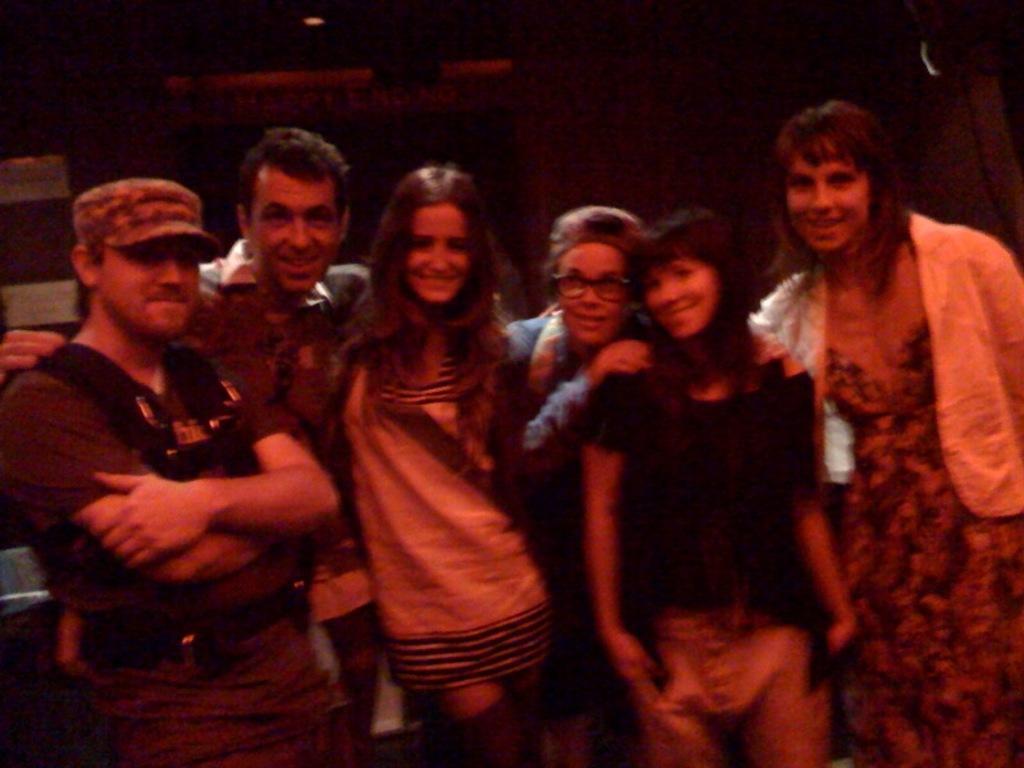In one or two sentences, can you explain what this image depicts? In the image there are group of peoples, on the right side there are two boys. In the middle both are girls and both are wearing spectacles. On the left side both are girls and both are having short hair. 